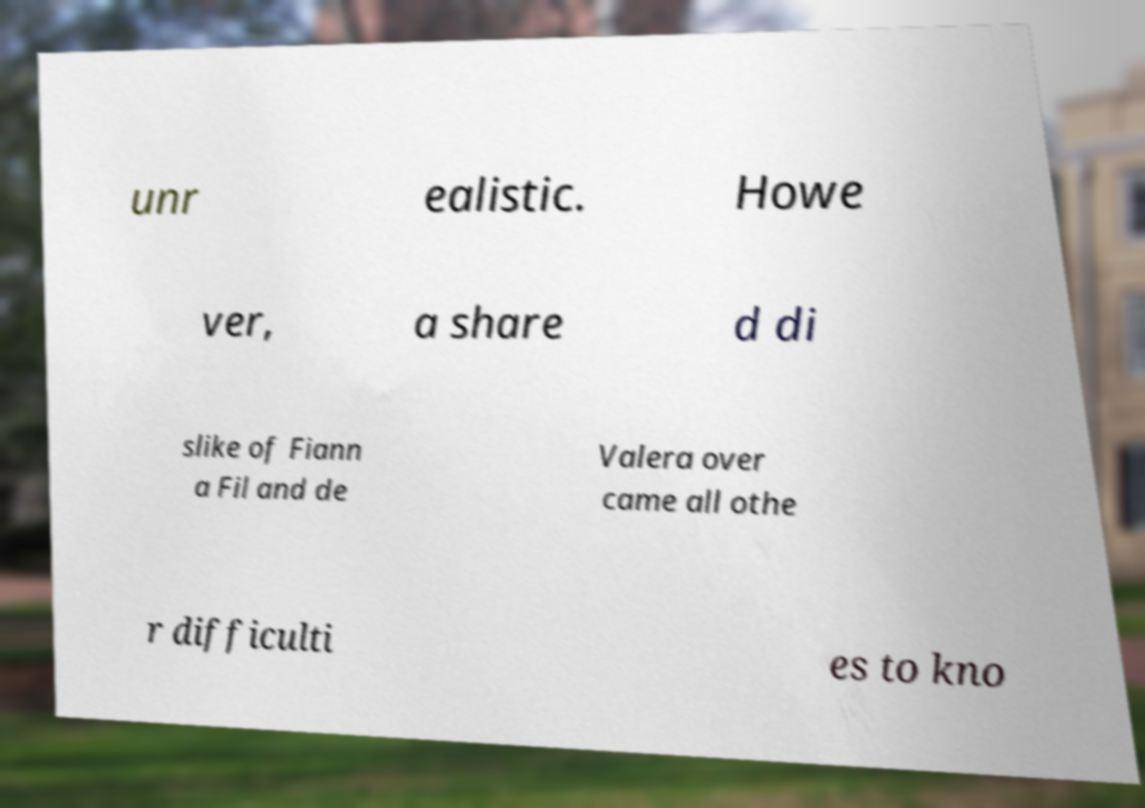Could you assist in decoding the text presented in this image and type it out clearly? unr ealistic. Howe ver, a share d di slike of Fiann a Fil and de Valera over came all othe r difficulti es to kno 